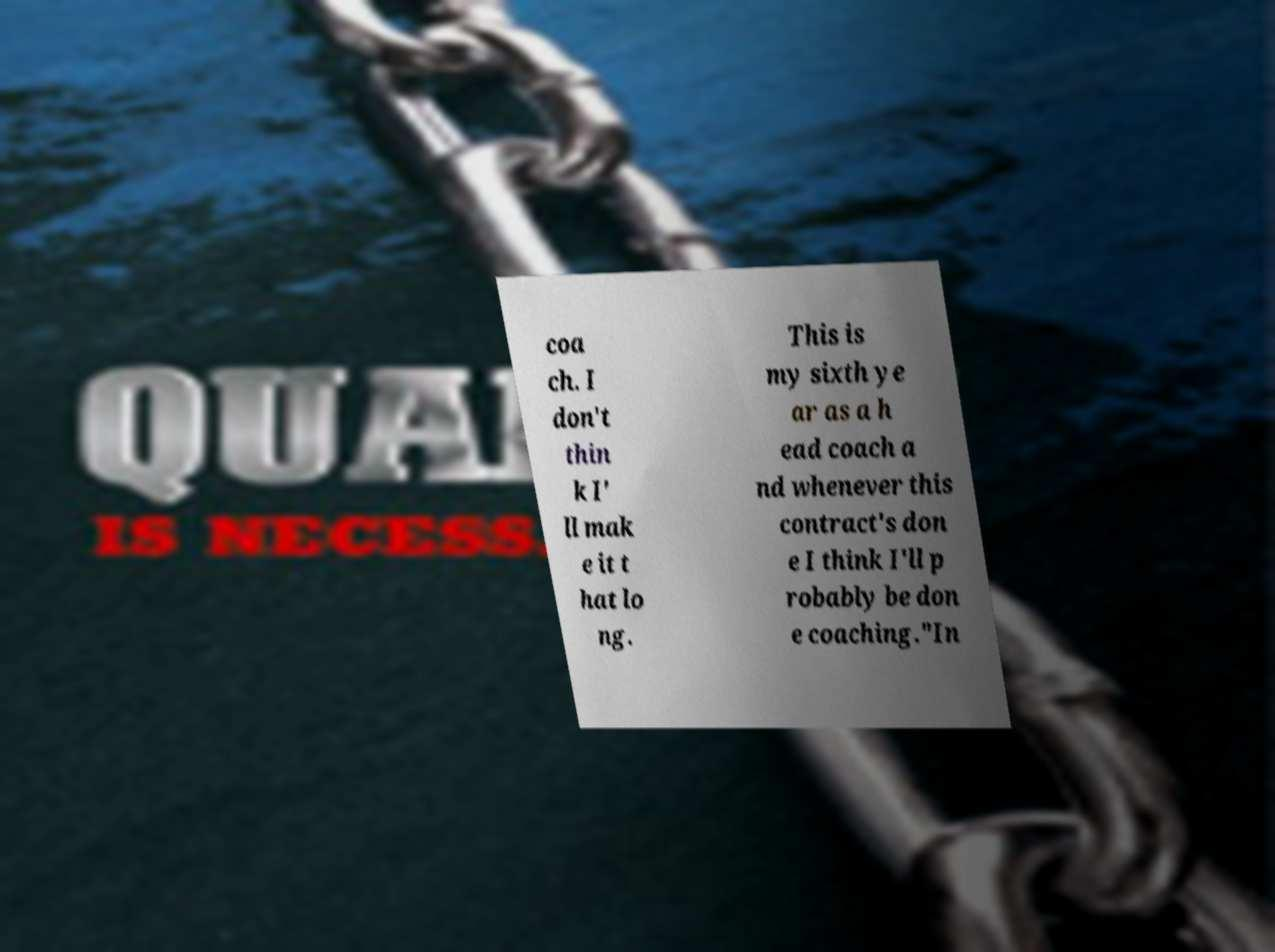Can you accurately transcribe the text from the provided image for me? coa ch. I don't thin k I' ll mak e it t hat lo ng. This is my sixth ye ar as a h ead coach a nd whenever this contract's don e I think I'll p robably be don e coaching."In 